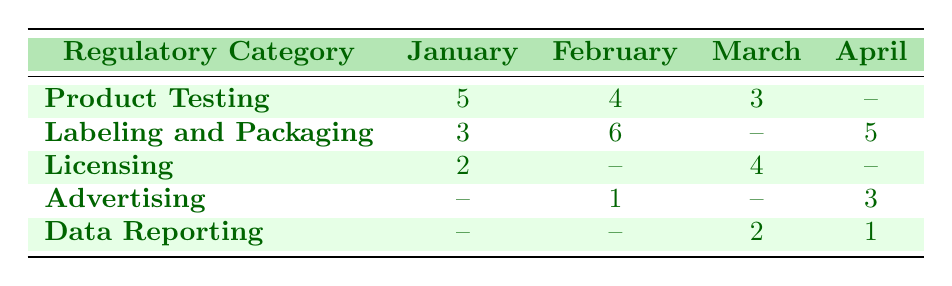What is the total number of compliance incidents for Product Testing from January to April? The incidents for Product Testing in the given months are: January (5), February (4), March (3), and April (0). To find the total, we sum these values: 5 + 4 + 3 + 0 = 12.
Answer: 12 How many compliance incidents occurred in February for Labeling and Packaging? The table shows that the incident count for Labeling and Packaging in February is 6.
Answer: 6 Is there any incident report for Advertising in January? According to the table, there are no reported incidents for Advertising in January, which is indicated by a "--" in that cell.
Answer: No Which month has the highest number of compliance incidents for Licensing? The incident counts for Licensing are: January (2), February (0), March (4), and April (0). The highest count is in March with 4 incidents.
Answer: March What is the average number of incidents for Data Reporting across all months? The counts for Data Reporting are as follows: January (0), February (0), March (2), and April (1). To find the average, we sum the values: 0 + 0 + 2 + 1 = 3, and then divide by the number of months (4): 3 / 4 = 0.75.
Answer: 0.75 In which month was there a compliance incident for Licensing, and how many were there? The table indicates incidents for Licensing in January (2) and March (4). Therefore, there were incidents in both months with counts as stated.
Answer: January (2), March (4) What is the difference between the number of incidents for Labeling and Packaging in January and in April? For Labeling and Packaging, the counts in January is 3 and in April is 5. The difference is calculated by subtracting the January count from the April count: 5 - 3 = 2.
Answer: 2 True or False: There were more compliance incidents for Labeling and Packaging in February than in January. In February, the incident count for Labeling and Packaging is 6, while in January it is 3. Since 6 is greater than 3, the statement is true.
Answer: True What is the total number of incidents across all categories in March? Adding the incident counts for March: Product Testing (3), Licensing (4), and Data Reporting (2) gives us a total of 3 + 4 + 2 = 9 incidents. April and Advertising have counts of 0 in March, so we only consider these three categories.
Answer: 9 